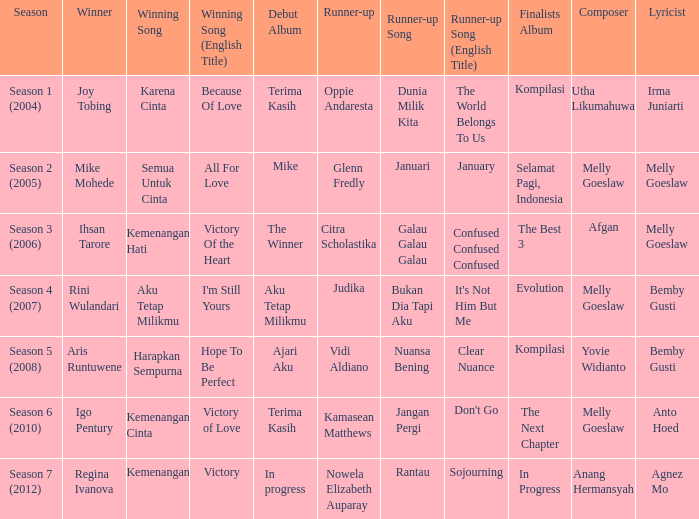Which English winning song had the winner aris runtuwene? Hope To Be Perfect. 